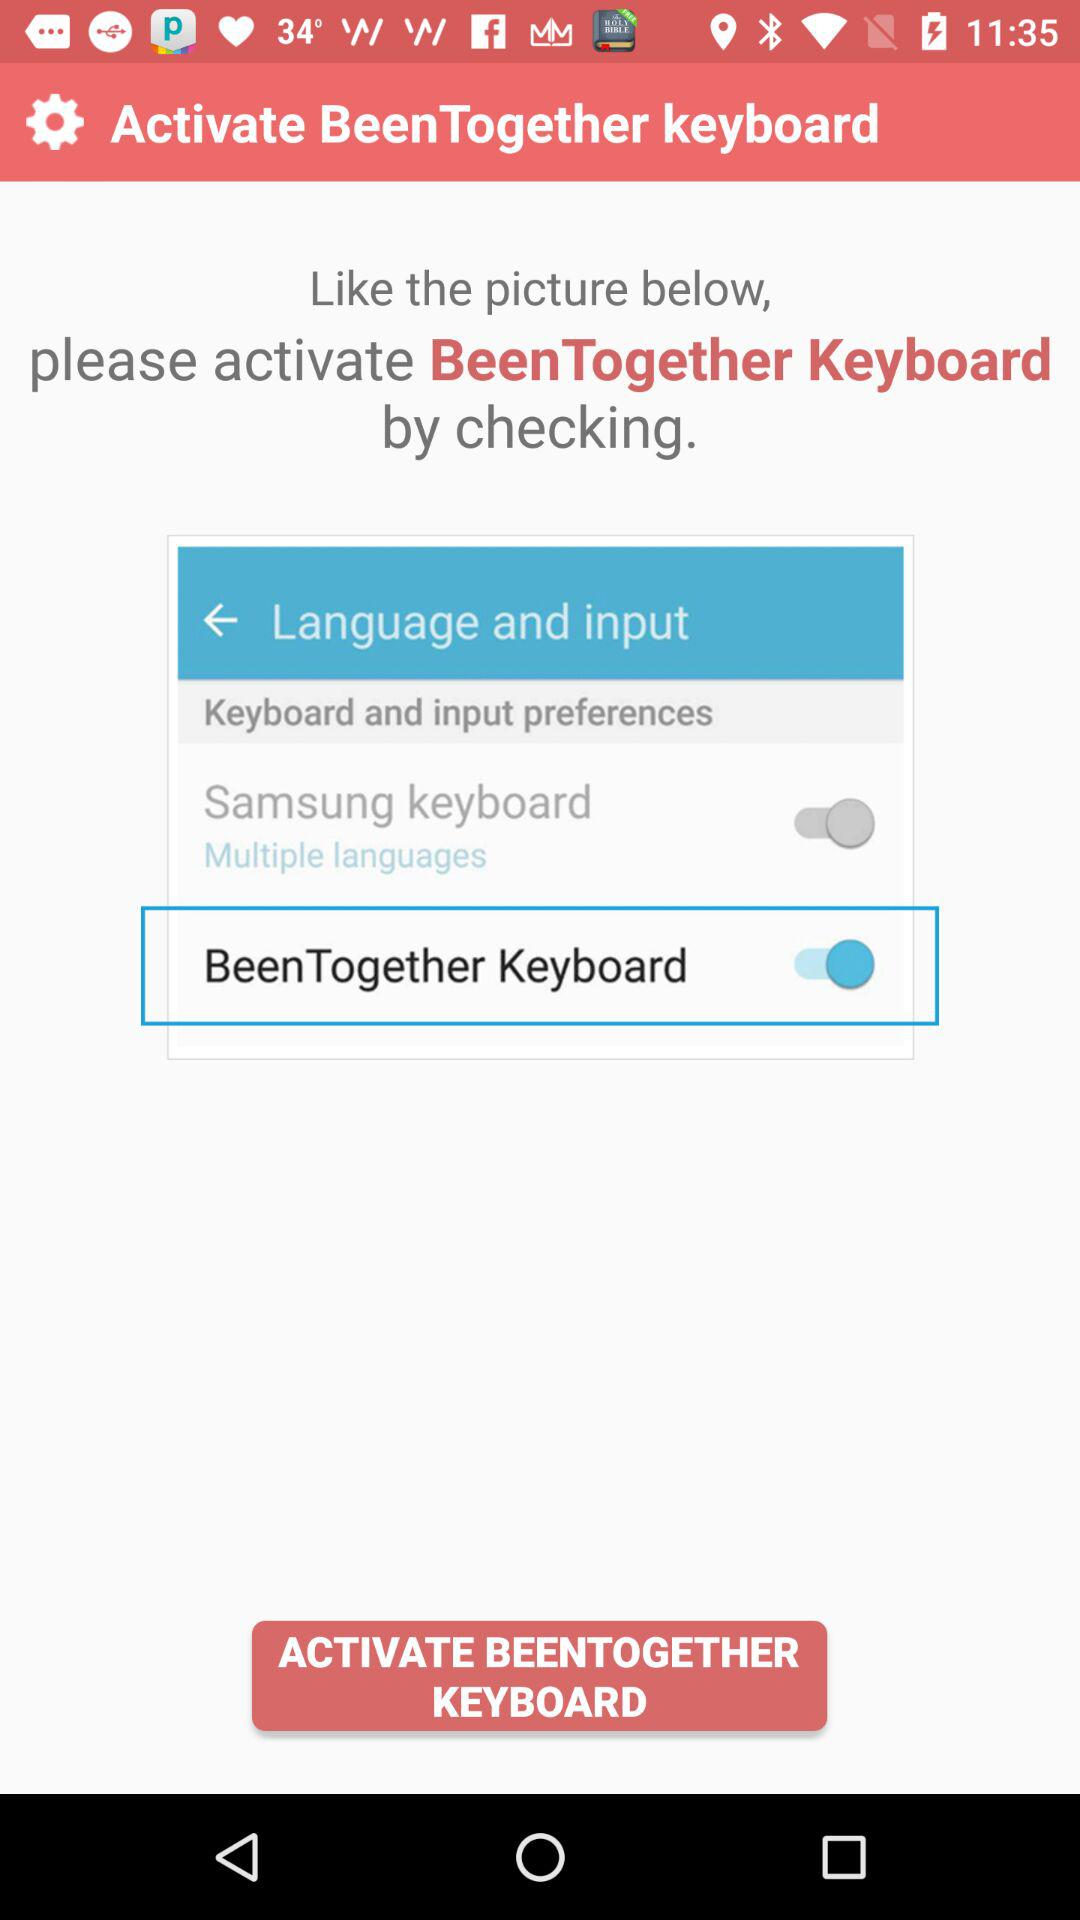How many more labels are there than switches?
Answer the question using a single word or phrase. 1 